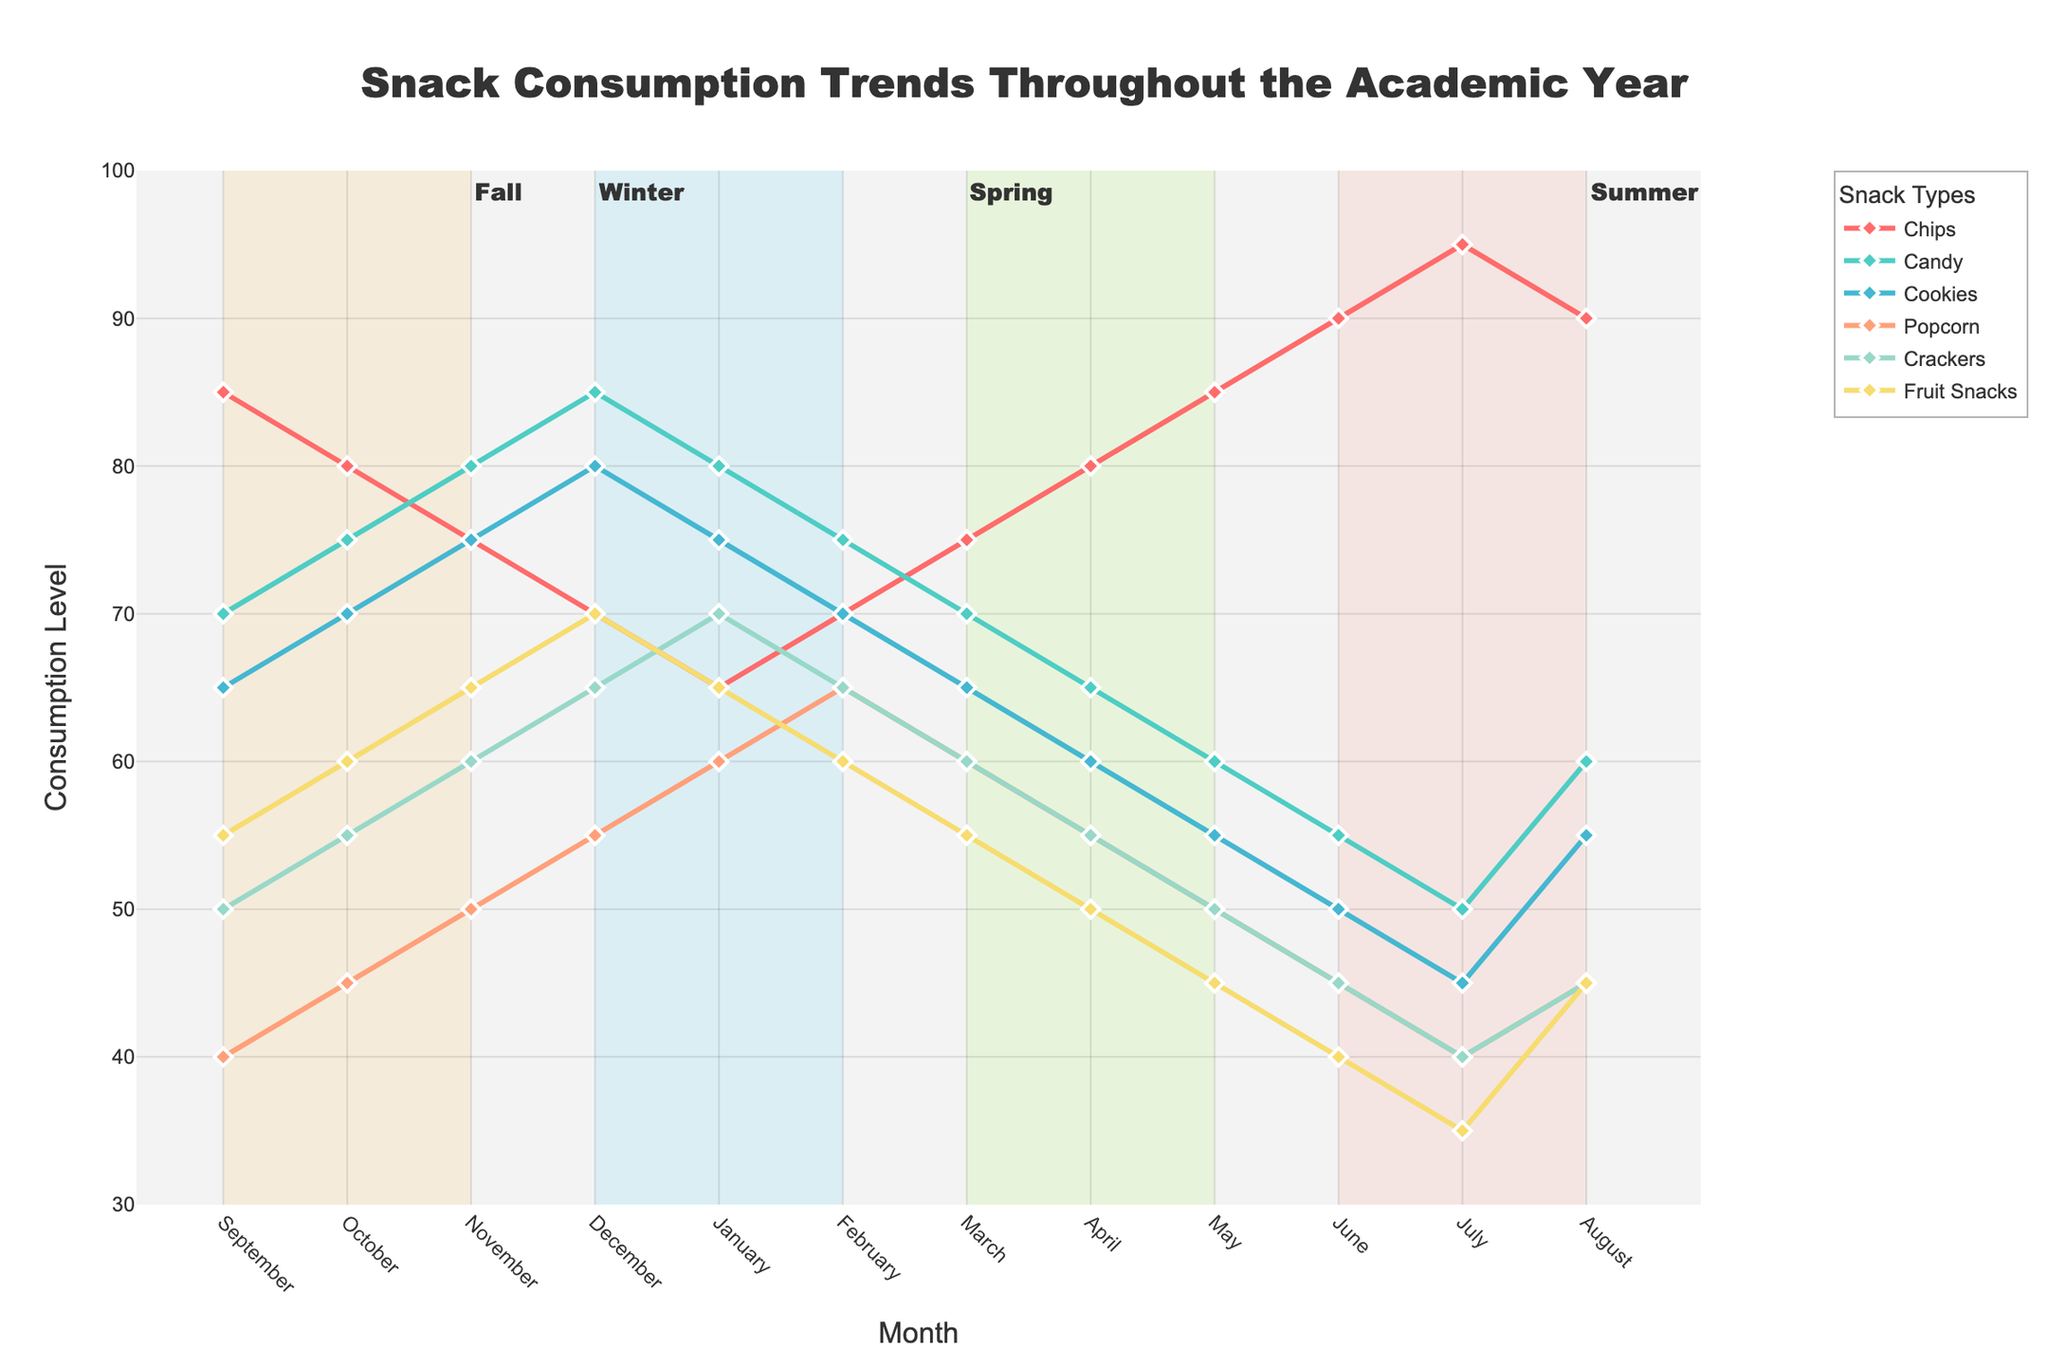What is the overall trend for Chips throughout the academic year? To determine the overall trend for Chips, look at the line representing Chips consumption across the months. The line generally increases from September to July. It starts at 85 in September, dips slightly during the winter months, and peaks in July at 95.
Answer: Increasing In which month is Candy consumption highest? Examine the line representing Candy consumption. The highest point on this line is in December when the value reaches 85.
Answer: December How does Cookie consumption in April compare to March? Look at the values for Cookies in March and April. In March, Cookie consumption is 65, while in April, it is 60. Therefore, Cookie consumption decreases from March to April.
Answer: Decreases Which snack has the lowest consumption in June? For June, compare the consumption levels of all snacks. Candy, with a value of 55, has the next highest consumption after Chips. Thus, comparing them directly, Chips has the lowest consumption.
Answer: Fruit Snacks What is the average consumption level of Popcorn over the academic year? Sum the values for Popcorn across all months and divide by 12. The total consumption is (40 + 45 + 50 + 55 + 60 + 65 + 60 + 55 + 50 + 45 + 40 + 45) = 610. The average is 610/12.
Answer: 50.83 (approximately 51) How do Popcorn and Crackers consumption patterns differ during the Spring season (March-May)? In March, Popcorn is 60 and Crackers is 60. In April, Popcorn decreases to 55 and Crackers also decreases to 55. In May, Popcorn further decreases to 50 and Crackers decreases to 50 as well. Both show a decreasing pattern but at the same decrement value for these months.
Answer: Both decrease What is the difference in Chips consumption between January and July? Subtract the January value for Chips (65) from the July value (95): 95 - 65.
Answer: 30 In which season is Fruit Snacks intake the lowest? Segment the data by seasons: Fall (Sep-Nov), Winter (Dec-Feb), Spring (Mar-May), Summer (Jun-Aug). Fruit Snacks consumption in Fall is (55 + 60 + 65)/3 = 60. In Winter, it's (70 + 65 + 60)/3 = 65. In Spring, it's (55 + 50 + 45)/3 = 50. In Summer, it's (40 + 35 + 45)/3 = 40. The lowest average is in Summer.
Answer: Summer How does overall snack consumption in May compare to December? Sum all snack consumptions for May (85 + 60 + 55 + 50 + 50 + 45) = 345 and for December (70 + 85 + 80 + 55 + 65 + 70) = 425. Compare the totals.
Answer: Higher in December Which two snacks have the most similar consumption patterns throughout the year? Analyze the lines for each snack. Popcorn and Crackers have very similar patterns, generally decreasing over the months with similar values. Popcorn is slightly higher in the earlier months but they follow a nearly parallel decreasing path.
Answer: Popcorn and Crackers 